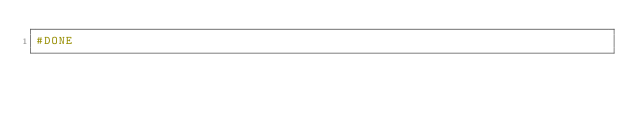<code> <loc_0><loc_0><loc_500><loc_500><_Python_>#DONE</code> 